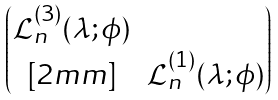Convert formula to latex. <formula><loc_0><loc_0><loc_500><loc_500>\begin{pmatrix} \mathcal { L } _ { n } ^ { ( 3 ) } ( \lambda ; \phi ) & \\ [ 2 m m ] & \mathcal { L } _ { n } ^ { ( 1 ) } ( \lambda ; \phi ) \end{pmatrix}</formula> 